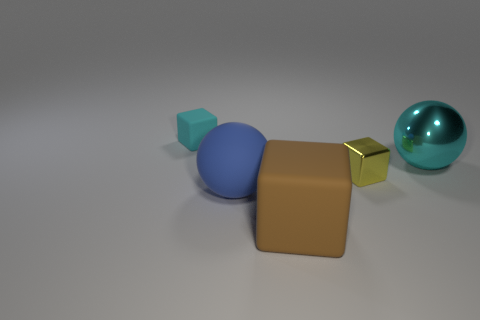Add 2 green matte balls. How many objects exist? 7 Subtract all brown blocks. How many blocks are left? 2 Add 5 tiny red matte cylinders. How many tiny red matte cylinders exist? 5 Subtract all rubber blocks. How many blocks are left? 1 Subtract 1 blue spheres. How many objects are left? 4 Subtract all blocks. How many objects are left? 2 Subtract all brown blocks. Subtract all purple cylinders. How many blocks are left? 2 Subtract all cyan balls. How many brown blocks are left? 1 Subtract all tiny cyan rubber things. Subtract all big blue rubber spheres. How many objects are left? 3 Add 1 tiny cyan rubber cubes. How many tiny cyan rubber cubes are left? 2 